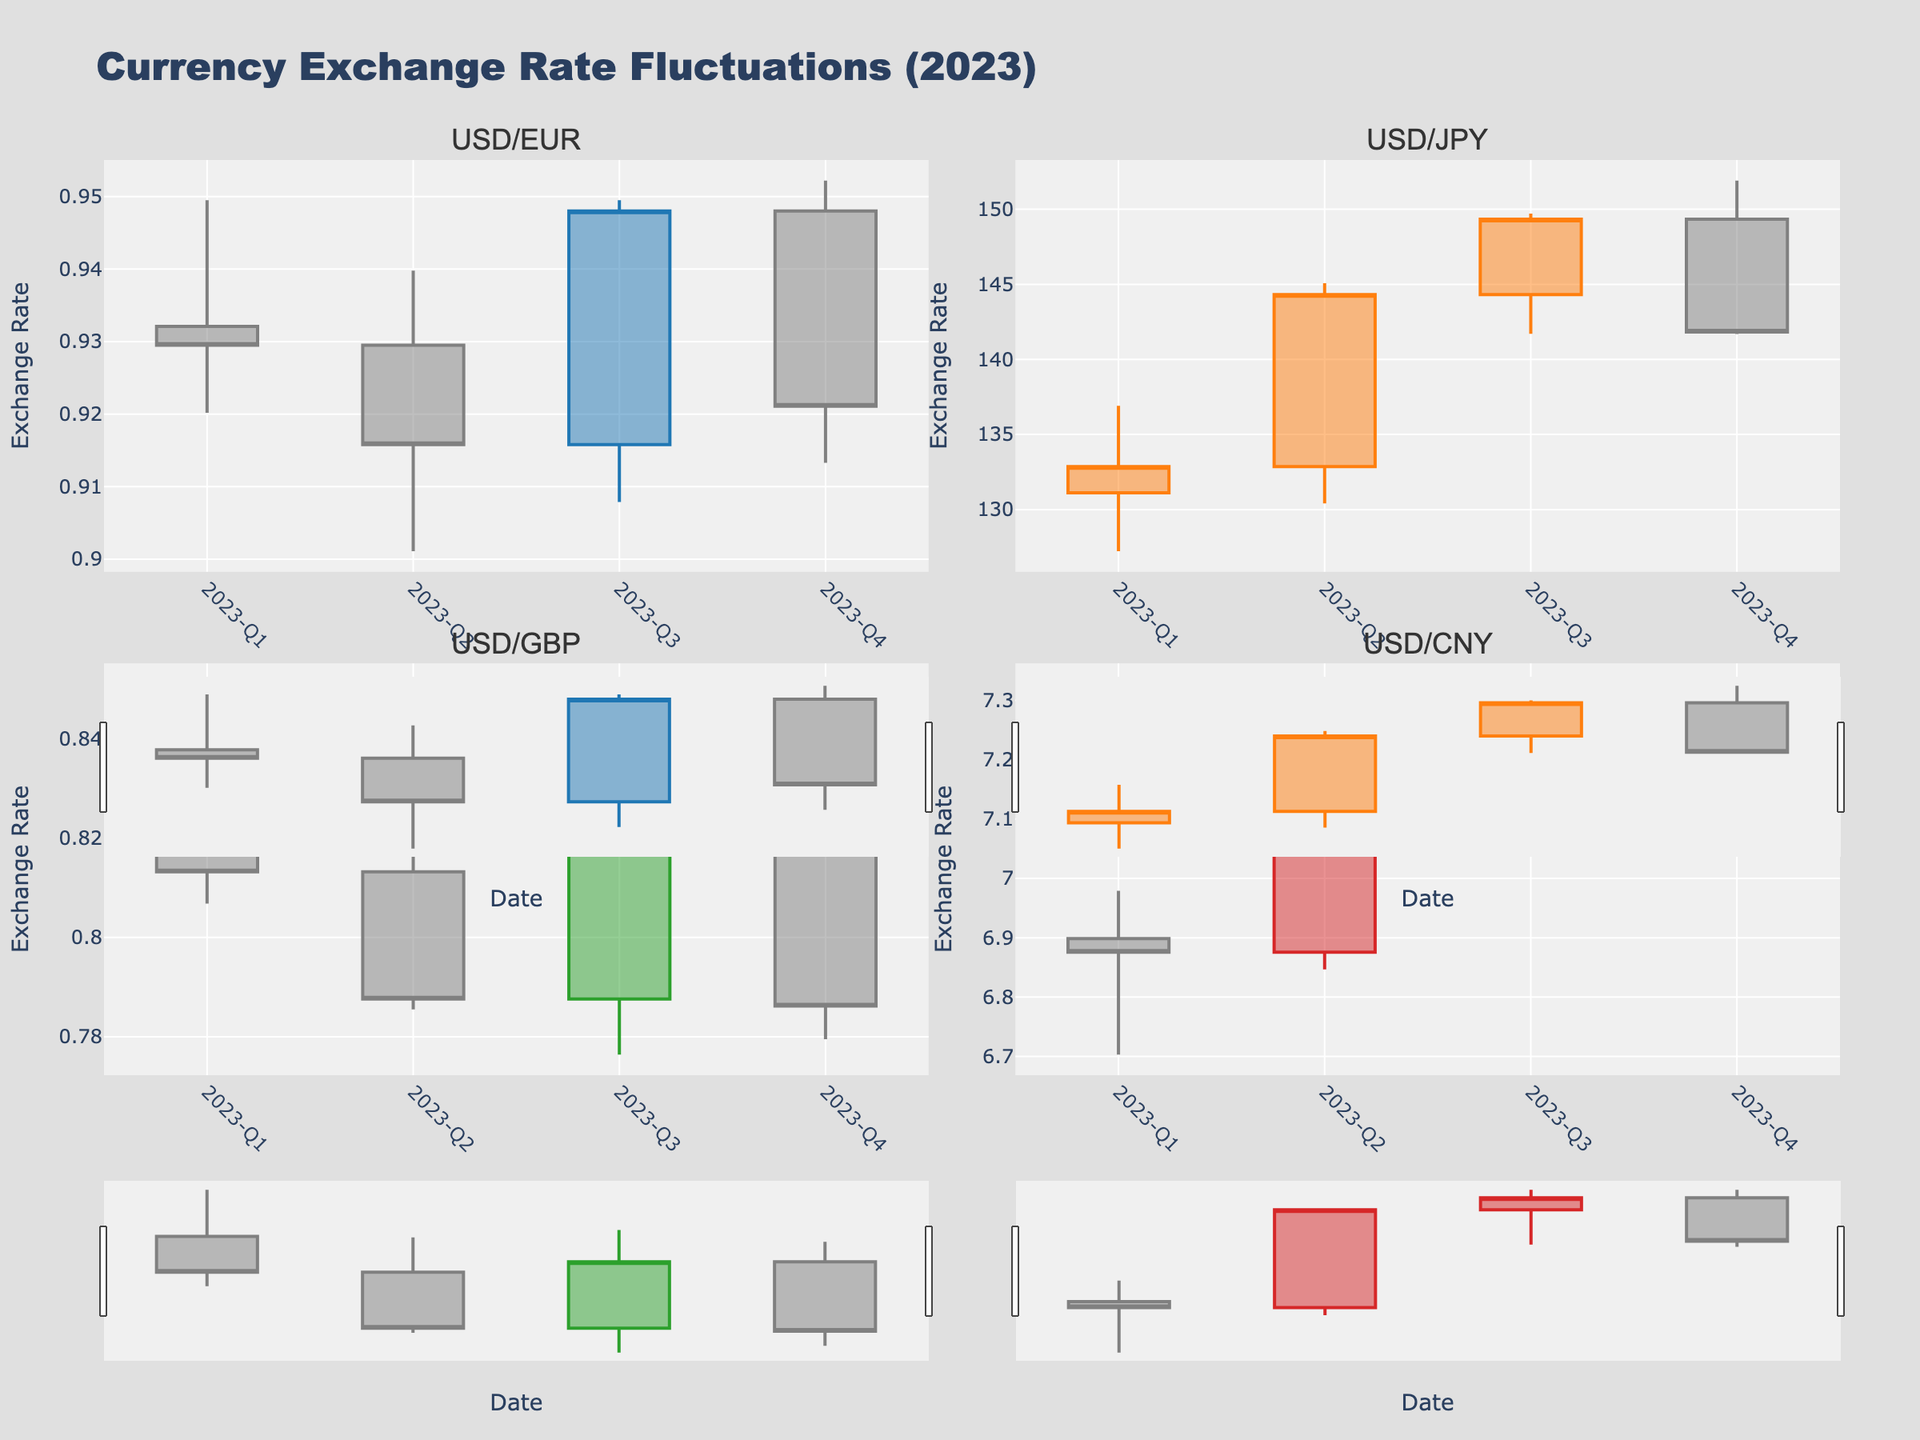what's the title of the figure? The title of the figure is prominently displayed at the top. It reads "Currency Exchange Rate Fluctuations (2023)".
Answer: Currency Exchange Rate Fluctuations (2023) How does the USD/EUR exchange rate trend from Q1 to Q4 2023? Observing the OHLC chart for USD/EUR, the Closing prices over each quarter are: Q1 (0.9295), Q2 (0.9158), Q3 (0.9480), Q4 (0.9211). The trend shows an initial decrease from Q1 to Q2, a rise in Q3, and another drop in Q4.
Answer: Decrease, increase, decrease What is the highest value observed for the USD/JPY exchange rate, and in which quarter does it occur? The highest value is the highest point on the "High" data in the OHLC chart for USD/JPY. It reaches 151.91 in Q4.
Answer: 151.91 in Q4 What percentage increase in the closing value does the USD/CNY exchange rate see between Q2 and Q3 2023? The closing values are Q2 (7.2513) and Q3 (7.2969). The percentage increase is calculated as ((7.2969 - 7.2513) / 7.2513) * 100. This results in approximately 0.63%.
Answer: Approximately 0.63% Which currency pair shows the most consistent decline in the exchange rate throughout 2023? By comparing the OHLC charts, we look for consistent decreases in the Closing values each quarter. USD/GBP shows a consistent decline: Q1 (0.8132), Q2 (0.7876), Q3 (0.8180), Q4 (0.7862).
Answer: USD/GBP What is the average closing rate for USD/CNY from Q1 to Q4 2023? The closing rates for each quarter are Q1(6.8755), Q2(7.2513), Q3(7.2969), Q4(7.1308). The average is calculated as (6.8755 + 7.2513 + 7.2969 + 7.1308) / 4 = 7.1386.
Answer: 7.1386 Which quarter has the highest volatility for USD/EUR based on the spread between the high and low prices? Volatility can be observed from the spread between the high and low values. For each quarter, the spreads are: Q1 (0.9495-0.9202=0.0293), Q2 (0.9398-0.9011=0.0387), Q3 (0.9495-0.9079=0.0416), Q4 (0.9522-0.9133=0.0389). Q3 has the highest volatility with a spread of 0.0416.
Answer: Q3 How does the closing rate for USD/JPY in Q3 2023 compare to Q4 2023? The closing rates for USD/JPY in Q3 is 149.34 and in Q4 is 141.83. Comparing these rates shows a decrease in the closing rate from Q3 to Q4.
Answer: Decrease Which currency pair has the overall highest closing rate in Q4 2023? Reviewing the closing rates in Q4, we see: USD/EUR (0.9211), USD/JPY (141.83), USD/GBP (0.7862), USD/CNY (7.1308). The highest closing rate is for USD/JPY at 141.83.
Answer: USD/JPY 